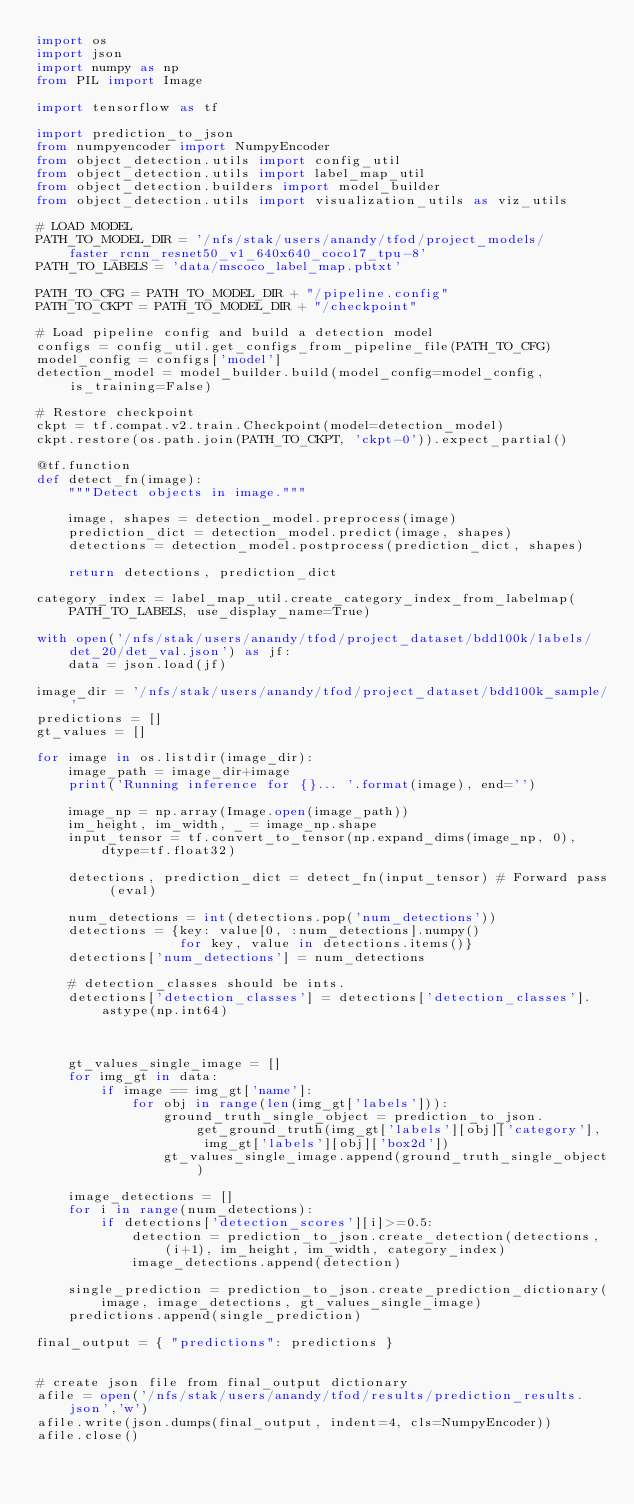Convert code to text. <code><loc_0><loc_0><loc_500><loc_500><_Python_>import os
import json
import numpy as np
from PIL import Image

import tensorflow as tf

import prediction_to_json
from numpyencoder import NumpyEncoder
from object_detection.utils import config_util
from object_detection.utils import label_map_util
from object_detection.builders import model_builder
from object_detection.utils import visualization_utils as viz_utils

# LOAD MODEL
PATH_TO_MODEL_DIR = '/nfs/stak/users/anandy/tfod/project_models/faster_rcnn_resnet50_v1_640x640_coco17_tpu-8'
PATH_TO_LABELS = 'data/mscoco_label_map.pbtxt'

PATH_TO_CFG = PATH_TO_MODEL_DIR + "/pipeline.config"
PATH_TO_CKPT = PATH_TO_MODEL_DIR + "/checkpoint"

# Load pipeline config and build a detection model
configs = config_util.get_configs_from_pipeline_file(PATH_TO_CFG)
model_config = configs['model']
detection_model = model_builder.build(model_config=model_config, is_training=False)

# Restore checkpoint
ckpt = tf.compat.v2.train.Checkpoint(model=detection_model)
ckpt.restore(os.path.join(PATH_TO_CKPT, 'ckpt-0')).expect_partial()

@tf.function
def detect_fn(image):
    """Detect objects in image."""

    image, shapes = detection_model.preprocess(image)
    prediction_dict = detection_model.predict(image, shapes)
    detections = detection_model.postprocess(prediction_dict, shapes)

    return detections, prediction_dict

category_index = label_map_util.create_category_index_from_labelmap(PATH_TO_LABELS, use_display_name=True)

with open('/nfs/stak/users/anandy/tfod/project_dataset/bdd100k/labels/det_20/det_val.json') as jf:
    data = json.load(jf)

image_dir = '/nfs/stak/users/anandy/tfod/project_dataset/bdd100k_sample/'
predictions = []
gt_values = []

for image in os.listdir(image_dir):
    image_path = image_dir+image
    print('Running inference for {}... '.format(image), end='')

    image_np = np.array(Image.open(image_path))
    im_height, im_width, _ = image_np.shape
    input_tensor = tf.convert_to_tensor(np.expand_dims(image_np, 0), dtype=tf.float32)

    detections, prediction_dict = detect_fn(input_tensor) # Forward pass (eval)
   
    num_detections = int(detections.pop('num_detections'))
    detections = {key: value[0, :num_detections].numpy()
                  for key, value in detections.items()}
    detections['num_detections'] = num_detections

    # detection_classes should be ints.
    detections['detection_classes'] = detections['detection_classes'].astype(np.int64)



    gt_values_single_image = []
    for img_gt in data:
        if image == img_gt['name']:
            for obj in range(len(img_gt['labels'])):
                ground_truth_single_object = prediction_to_json.get_ground_truth(img_gt['labels'][obj]['category'], img_gt['labels'][obj]['box2d'])
                gt_values_single_image.append(ground_truth_single_object)

    image_detections = []
    for i in range(num_detections):
        if detections['detection_scores'][i]>=0.5:
            detection = prediction_to_json.create_detection(detections, (i+1), im_height, im_width, category_index)
            image_detections.append(detection)
            
    single_prediction = prediction_to_json.create_prediction_dictionary(image, image_detections, gt_values_single_image)
    predictions.append(single_prediction)

final_output = { "predictions": predictions }


# create json file from final_output dictionary
afile = open('/nfs/stak/users/anandy/tfod/results/prediction_results.json','w')
afile.write(json.dumps(final_output, indent=4, cls=NumpyEncoder))
afile.close()</code> 